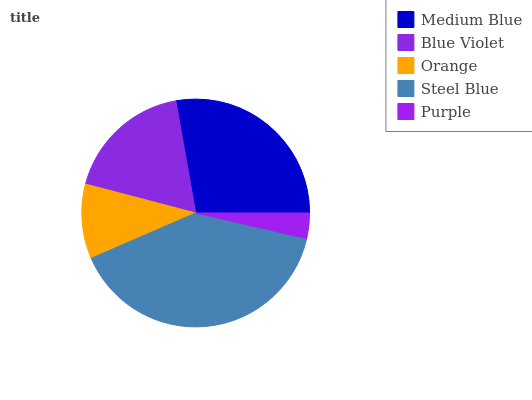Is Purple the minimum?
Answer yes or no. Yes. Is Steel Blue the maximum?
Answer yes or no. Yes. Is Blue Violet the minimum?
Answer yes or no. No. Is Blue Violet the maximum?
Answer yes or no. No. Is Medium Blue greater than Blue Violet?
Answer yes or no. Yes. Is Blue Violet less than Medium Blue?
Answer yes or no. Yes. Is Blue Violet greater than Medium Blue?
Answer yes or no. No. Is Medium Blue less than Blue Violet?
Answer yes or no. No. Is Blue Violet the high median?
Answer yes or no. Yes. Is Blue Violet the low median?
Answer yes or no. Yes. Is Orange the high median?
Answer yes or no. No. Is Steel Blue the low median?
Answer yes or no. No. 